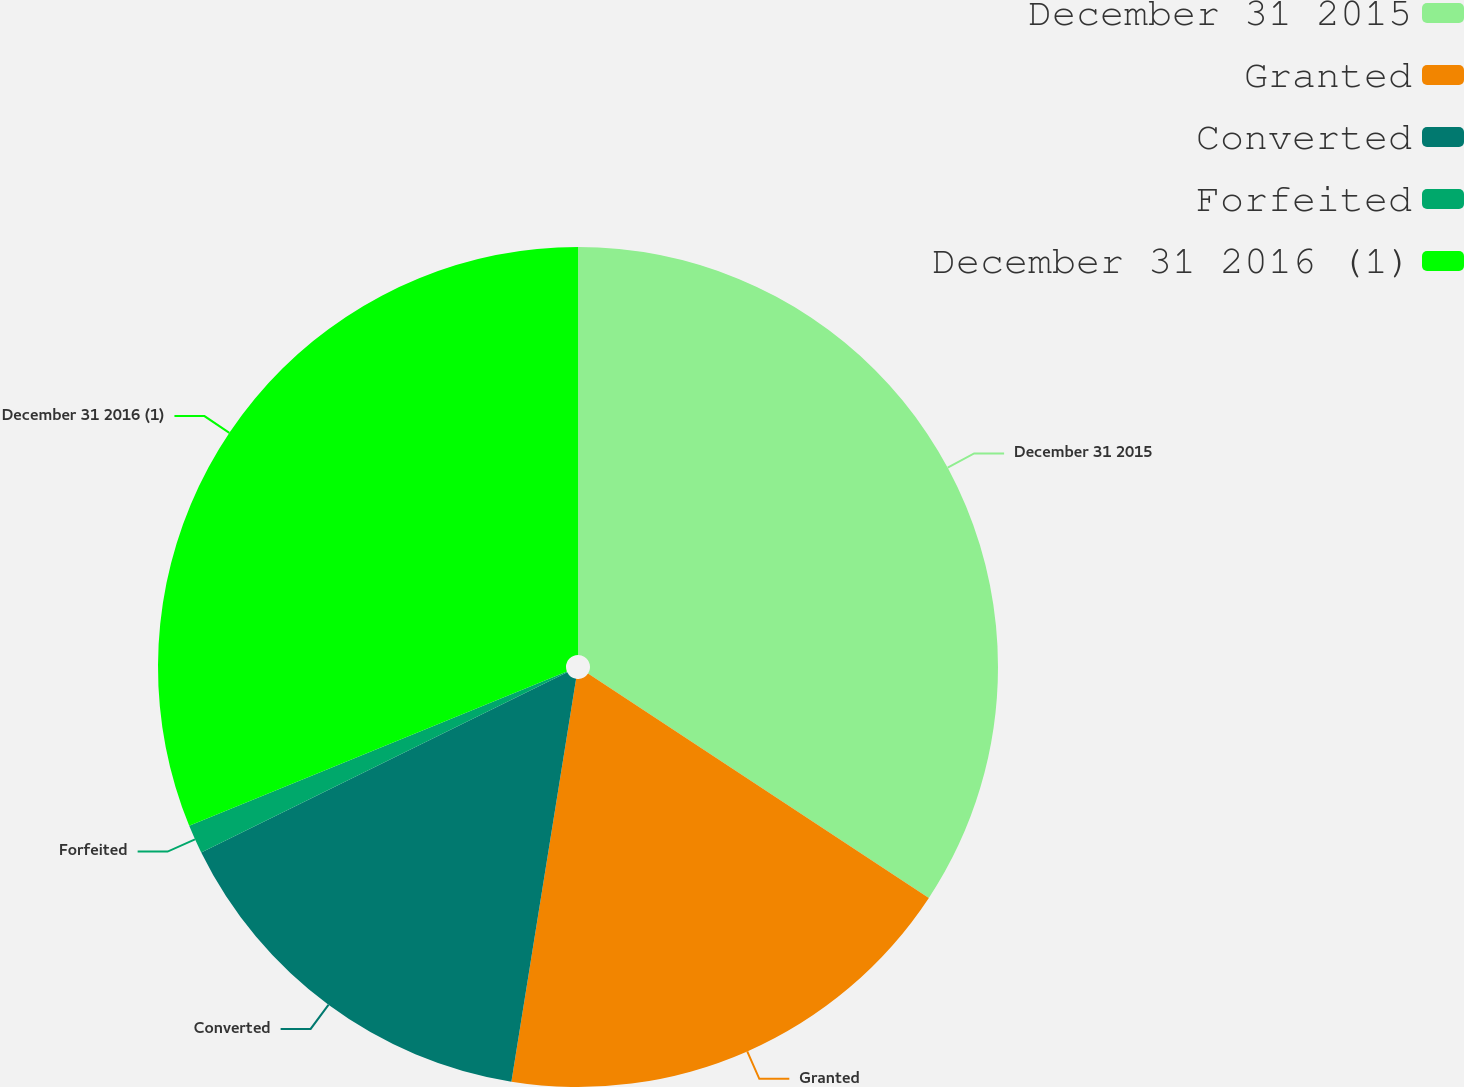Convert chart. <chart><loc_0><loc_0><loc_500><loc_500><pie_chart><fcel>December 31 2015<fcel>Granted<fcel>Converted<fcel>Forfeited<fcel>December 31 2016 (1)<nl><fcel>34.26%<fcel>18.27%<fcel>15.18%<fcel>1.11%<fcel>31.17%<nl></chart> 